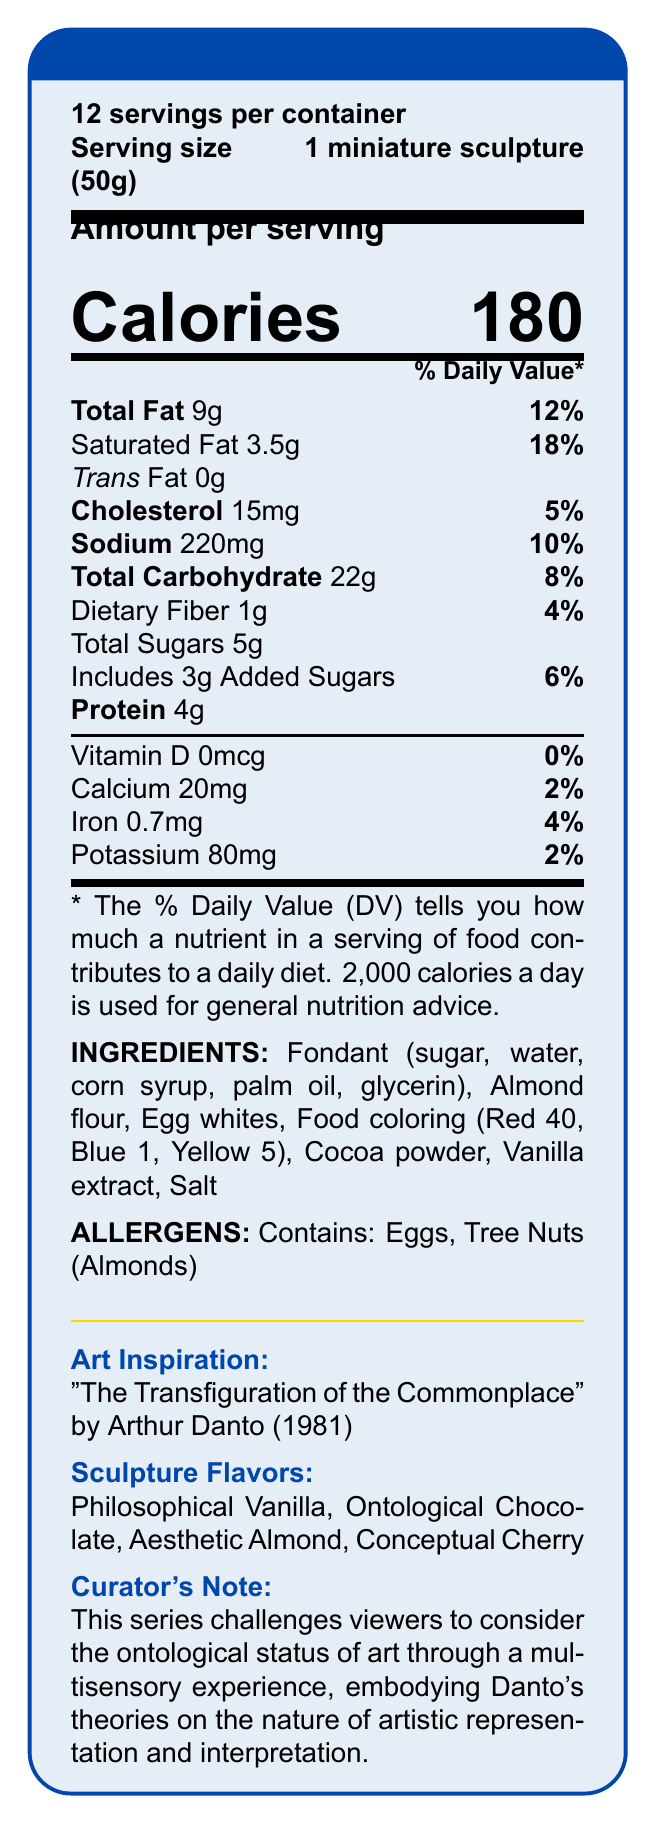how many servings are in the container? The document states there are 12 servings per container.
Answer: 12 servings what is the serving size? The serving size is specified as 1 miniature sculpture weighing 50g.
Answer: 1 miniature sculpture (50g) how many calories are in one serving? The document indicates there are 180 calories per serving.
Answer: 180 calories what is the total fat content per serving? The total fat content per serving is 9 grams.
Answer: 9g how many grams of protein are in a serving? Each serving contains 4 grams of protein.
Answer: 4g which flavors are the sculptures available in? The sculpture flavors listed are Philosophical Vanilla, Ontological Chocolate, Aesthetic Almond, and Conceptual Cherry.
Answer: Philosophical Vanilla, Ontological Chocolate, Aesthetic Almond, Conceptual Cherry what are the primary allergens listed? The document mentions that the sculptures contain eggs and tree nuts (almonds) as allergens.
Answer: Eggs, Tree Nuts (Almonds) how much sodium does one serving contain? Each serving contains 220 milligrams of sodium.
Answer: 220mg what percentage of the daily value for saturated fat does one serving contain? One serving provides 18% of the daily value for saturated fat.
Answer: 18% what year was "The Transfiguration of the Commonplace" by Arthur Danto created? The art inspiration piece mentioned in the document was created in 1981.
Answer: 1981 which ingredient is not used in the sculptures? A. Almond flour B. Egg whites C. Coconut oil D. Fondant The ingredients list does not include coconut oil.
Answer: C. Coconut oil how much cholesterol is in one serving? A. 10mg B. 15mg C. 20mg D. 5mg One serving contains 15mg of cholesterol.
Answer: B. 15mg does one serving contain any trans fat? The document specifies that there is 0g of trans fat per serving.
Answer: No is there any added sugar in the sculptures? The document states that each serving contains 3g of added sugars.
Answer: Yes summarize the key components of this document. The document overall provides nutritional details, ingredients, allergens, and artistic inspiration behind the sculptures, as well as serving size and count.
Answer: The document provides nutritional information for a series of edible sculptures inspired by Arthur Danto's "The Transfiguration of the Commonplace." Each serving is 50g and contains 180 calories. It details the fat, cholesterol, sodium, carbohydrate, and protein content per serving and lists the ingredients and allergens. The sculptures come in four flavors and challenge the perception of art and sustenance. what is the source of dietary fiber in the sculptures? The document lists the amount of dietary fiber but does not specify the source of dietary fiber directly.
Answer: Not enough information what is the philosophical concept behind these edible sculptures? The curator's note and nutritional statement indicate that these sculptures are created to challenge the boundaries of art and reality following Danto's philosophy.
Answer: To blur the lines between sustenance and artistic expression, embodying Danto's theories on art and reality. 